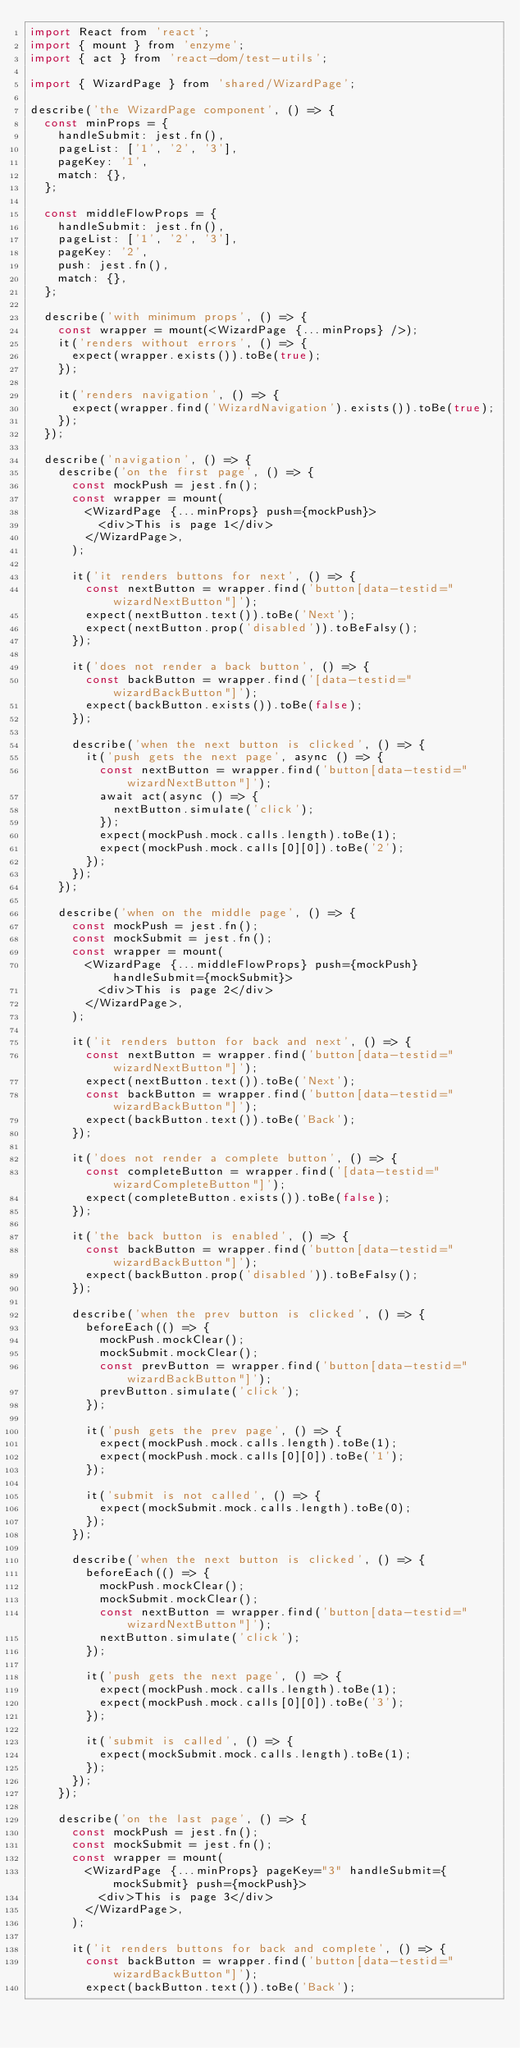Convert code to text. <code><loc_0><loc_0><loc_500><loc_500><_JavaScript_>import React from 'react';
import { mount } from 'enzyme';
import { act } from 'react-dom/test-utils';

import { WizardPage } from 'shared/WizardPage';

describe('the WizardPage component', () => {
  const minProps = {
    handleSubmit: jest.fn(),
    pageList: ['1', '2', '3'],
    pageKey: '1',
    match: {},
  };

  const middleFlowProps = {
    handleSubmit: jest.fn(),
    pageList: ['1', '2', '3'],
    pageKey: '2',
    push: jest.fn(),
    match: {},
  };

  describe('with minimum props', () => {
    const wrapper = mount(<WizardPage {...minProps} />);
    it('renders without errors', () => {
      expect(wrapper.exists()).toBe(true);
    });

    it('renders navigation', () => {
      expect(wrapper.find('WizardNavigation').exists()).toBe(true);
    });
  });

  describe('navigation', () => {
    describe('on the first page', () => {
      const mockPush = jest.fn();
      const wrapper = mount(
        <WizardPage {...minProps} push={mockPush}>
          <div>This is page 1</div>
        </WizardPage>,
      );

      it('it renders buttons for next', () => {
        const nextButton = wrapper.find('button[data-testid="wizardNextButton"]');
        expect(nextButton.text()).toBe('Next');
        expect(nextButton.prop('disabled')).toBeFalsy();
      });

      it('does not render a back button', () => {
        const backButton = wrapper.find('[data-testid="wizardBackButton"]');
        expect(backButton.exists()).toBe(false);
      });

      describe('when the next button is clicked', () => {
        it('push gets the next page', async () => {
          const nextButton = wrapper.find('button[data-testid="wizardNextButton"]');
          await act(async () => {
            nextButton.simulate('click');
          });
          expect(mockPush.mock.calls.length).toBe(1);
          expect(mockPush.mock.calls[0][0]).toBe('2');
        });
      });
    });

    describe('when on the middle page', () => {
      const mockPush = jest.fn();
      const mockSubmit = jest.fn();
      const wrapper = mount(
        <WizardPage {...middleFlowProps} push={mockPush} handleSubmit={mockSubmit}>
          <div>This is page 2</div>
        </WizardPage>,
      );

      it('it renders button for back and next', () => {
        const nextButton = wrapper.find('button[data-testid="wizardNextButton"]');
        expect(nextButton.text()).toBe('Next');
        const backButton = wrapper.find('button[data-testid="wizardBackButton"]');
        expect(backButton.text()).toBe('Back');
      });

      it('does not render a complete button', () => {
        const completeButton = wrapper.find('[data-testid="wizardCompleteButton"]');
        expect(completeButton.exists()).toBe(false);
      });

      it('the back button is enabled', () => {
        const backButton = wrapper.find('button[data-testid="wizardBackButton"]');
        expect(backButton.prop('disabled')).toBeFalsy();
      });

      describe('when the prev button is clicked', () => {
        beforeEach(() => {
          mockPush.mockClear();
          mockSubmit.mockClear();
          const prevButton = wrapper.find('button[data-testid="wizardBackButton"]');
          prevButton.simulate('click');
        });

        it('push gets the prev page', () => {
          expect(mockPush.mock.calls.length).toBe(1);
          expect(mockPush.mock.calls[0][0]).toBe('1');
        });

        it('submit is not called', () => {
          expect(mockSubmit.mock.calls.length).toBe(0);
        });
      });

      describe('when the next button is clicked', () => {
        beforeEach(() => {
          mockPush.mockClear();
          mockSubmit.mockClear();
          const nextButton = wrapper.find('button[data-testid="wizardNextButton"]');
          nextButton.simulate('click');
        });

        it('push gets the next page', () => {
          expect(mockPush.mock.calls.length).toBe(1);
          expect(mockPush.mock.calls[0][0]).toBe('3');
        });

        it('submit is called', () => {
          expect(mockSubmit.mock.calls.length).toBe(1);
        });
      });
    });

    describe('on the last page', () => {
      const mockPush = jest.fn();
      const mockSubmit = jest.fn();
      const wrapper = mount(
        <WizardPage {...minProps} pageKey="3" handleSubmit={mockSubmit} push={mockPush}>
          <div>This is page 3</div>
        </WizardPage>,
      );

      it('it renders buttons for back and complete', () => {
        const backButton = wrapper.find('button[data-testid="wizardBackButton"]');
        expect(backButton.text()).toBe('Back');</code> 